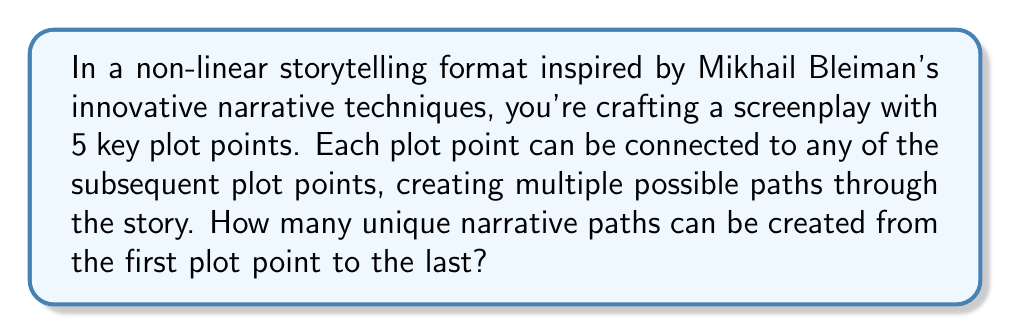Can you answer this question? Let's approach this step-by-step:

1) We have 5 plot points, which we can label as A, B, C, D, and E.

2) From each plot point, we can move to any of the subsequent points. This means:
   - From A, we can go to B, C, D, or E
   - From B, we can go to C, D, or E
   - From C, we can go to D or E
   - From D, we can only go to E

3) This scenario can be modeled as a directed acyclic graph, where each path from A to E represents a unique narrative path.

4) To count the number of paths, we can use dynamic programming:
   Let $P(i)$ be the number of paths from point i to E.

5) We can derive the following relations:
   $P(E) = 1$ (there's only one way to get from E to E)
   $P(D) = P(E) = 1$
   $P(C) = P(D) + P(E) = 1 + 1 = 2$
   $P(B) = P(C) + P(D) + P(E) = 2 + 1 + 1 = 4$
   $P(A) = P(B) + P(C) + P(D) + P(E) = 4 + 2 + 1 + 1 = 8$

6) The number of unique narrative paths from A to E is given by $P(A)$, which is 8.

This method is equivalent to counting the number of paths in a directed acyclic graph, which is a common problem in combinatorics and graph theory.
Answer: 8 